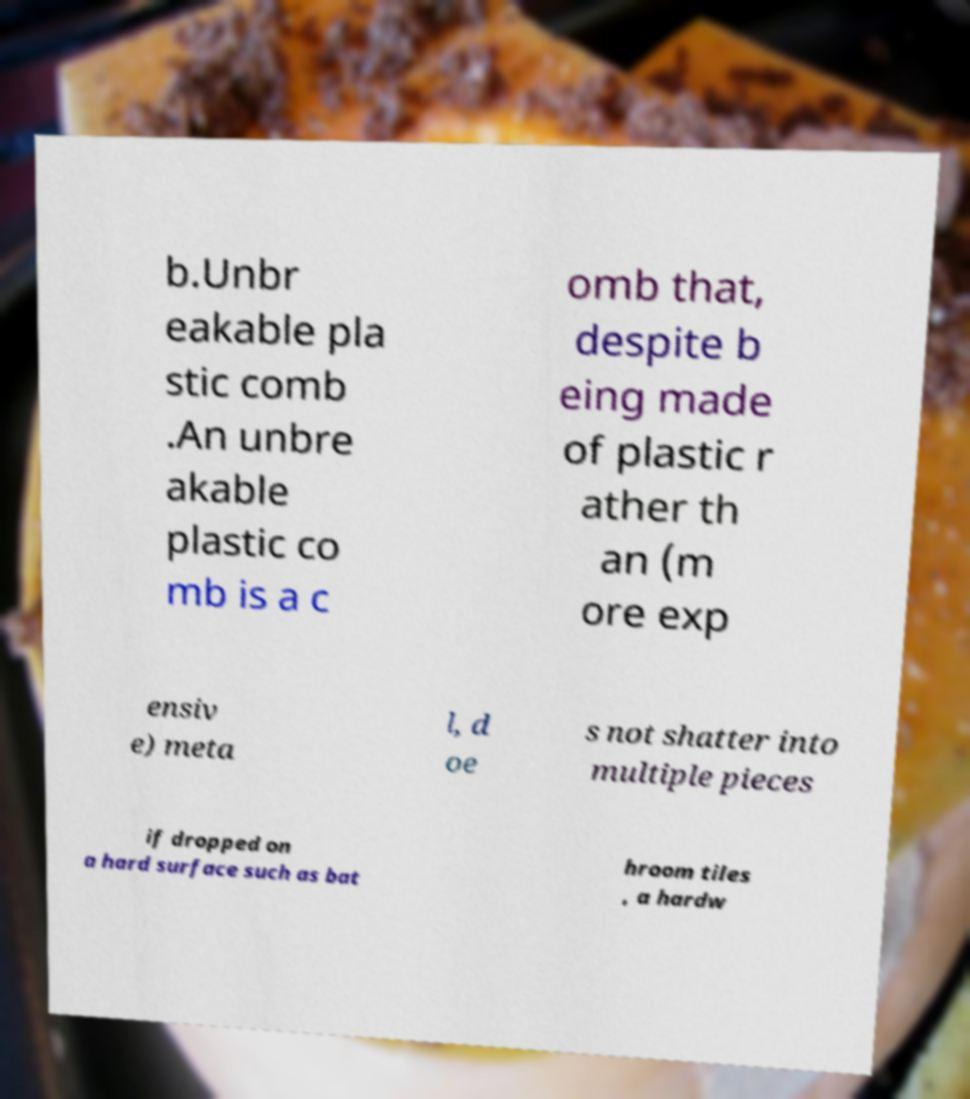What messages or text are displayed in this image? I need them in a readable, typed format. b.Unbr eakable pla stic comb .An unbre akable plastic co mb is a c omb that, despite b eing made of plastic r ather th an (m ore exp ensiv e) meta l, d oe s not shatter into multiple pieces if dropped on a hard surface such as bat hroom tiles , a hardw 